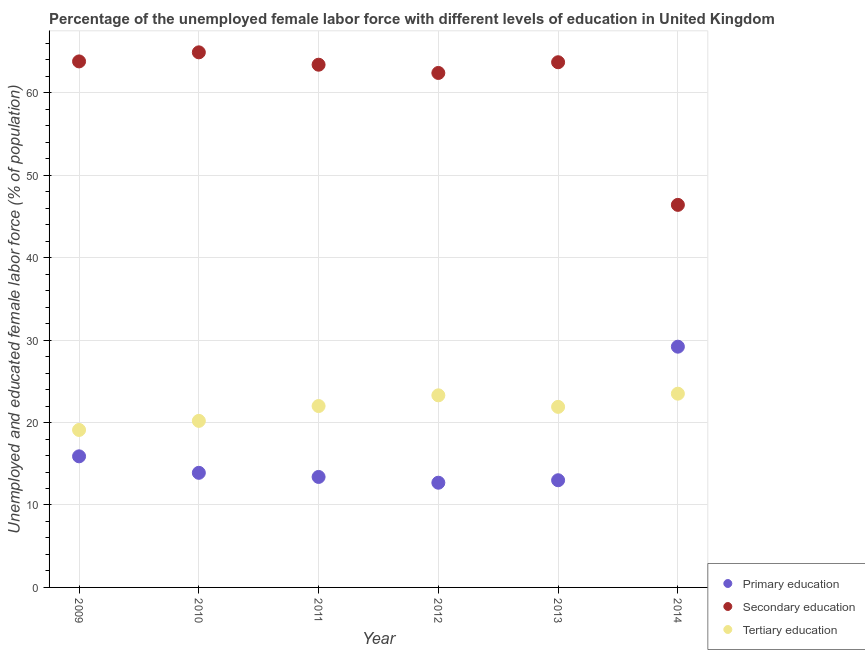How many different coloured dotlines are there?
Your answer should be compact. 3. Is the number of dotlines equal to the number of legend labels?
Offer a terse response. Yes. What is the percentage of female labor force who received primary education in 2011?
Ensure brevity in your answer.  13.4. Across all years, what is the minimum percentage of female labor force who received tertiary education?
Offer a terse response. 19.1. In which year was the percentage of female labor force who received secondary education maximum?
Your answer should be very brief. 2010. In which year was the percentage of female labor force who received secondary education minimum?
Offer a very short reply. 2014. What is the total percentage of female labor force who received tertiary education in the graph?
Your response must be concise. 130. What is the difference between the percentage of female labor force who received tertiary education in 2010 and that in 2011?
Your answer should be very brief. -1.8. What is the difference between the percentage of female labor force who received primary education in 2010 and the percentage of female labor force who received secondary education in 2014?
Ensure brevity in your answer.  -32.5. What is the average percentage of female labor force who received tertiary education per year?
Your answer should be very brief. 21.67. In the year 2010, what is the difference between the percentage of female labor force who received tertiary education and percentage of female labor force who received secondary education?
Your answer should be very brief. -44.7. In how many years, is the percentage of female labor force who received primary education greater than 58 %?
Make the answer very short. 0. What is the ratio of the percentage of female labor force who received primary education in 2009 to that in 2011?
Give a very brief answer. 1.19. Is the percentage of female labor force who received tertiary education in 2012 less than that in 2013?
Offer a terse response. No. What is the difference between the highest and the second highest percentage of female labor force who received tertiary education?
Offer a very short reply. 0.2. What is the difference between the highest and the lowest percentage of female labor force who received tertiary education?
Your answer should be very brief. 4.4. In how many years, is the percentage of female labor force who received secondary education greater than the average percentage of female labor force who received secondary education taken over all years?
Make the answer very short. 5. Is it the case that in every year, the sum of the percentage of female labor force who received primary education and percentage of female labor force who received secondary education is greater than the percentage of female labor force who received tertiary education?
Offer a very short reply. Yes. Does the percentage of female labor force who received primary education monotonically increase over the years?
Your answer should be very brief. No. How many dotlines are there?
Provide a short and direct response. 3. What is the difference between two consecutive major ticks on the Y-axis?
Offer a very short reply. 10. How many legend labels are there?
Make the answer very short. 3. What is the title of the graph?
Keep it short and to the point. Percentage of the unemployed female labor force with different levels of education in United Kingdom. What is the label or title of the X-axis?
Provide a short and direct response. Year. What is the label or title of the Y-axis?
Your answer should be compact. Unemployed and educated female labor force (% of population). What is the Unemployed and educated female labor force (% of population) in Primary education in 2009?
Offer a terse response. 15.9. What is the Unemployed and educated female labor force (% of population) in Secondary education in 2009?
Your response must be concise. 63.8. What is the Unemployed and educated female labor force (% of population) of Tertiary education in 2009?
Offer a very short reply. 19.1. What is the Unemployed and educated female labor force (% of population) in Primary education in 2010?
Provide a short and direct response. 13.9. What is the Unemployed and educated female labor force (% of population) in Secondary education in 2010?
Offer a terse response. 64.9. What is the Unemployed and educated female labor force (% of population) of Tertiary education in 2010?
Offer a terse response. 20.2. What is the Unemployed and educated female labor force (% of population) of Primary education in 2011?
Provide a succinct answer. 13.4. What is the Unemployed and educated female labor force (% of population) in Secondary education in 2011?
Provide a succinct answer. 63.4. What is the Unemployed and educated female labor force (% of population) of Primary education in 2012?
Offer a terse response. 12.7. What is the Unemployed and educated female labor force (% of population) of Secondary education in 2012?
Provide a succinct answer. 62.4. What is the Unemployed and educated female labor force (% of population) of Tertiary education in 2012?
Keep it short and to the point. 23.3. What is the Unemployed and educated female labor force (% of population) of Secondary education in 2013?
Make the answer very short. 63.7. What is the Unemployed and educated female labor force (% of population) in Tertiary education in 2013?
Make the answer very short. 21.9. What is the Unemployed and educated female labor force (% of population) of Primary education in 2014?
Make the answer very short. 29.2. What is the Unemployed and educated female labor force (% of population) in Secondary education in 2014?
Provide a succinct answer. 46.4. What is the Unemployed and educated female labor force (% of population) in Tertiary education in 2014?
Provide a short and direct response. 23.5. Across all years, what is the maximum Unemployed and educated female labor force (% of population) of Primary education?
Your answer should be compact. 29.2. Across all years, what is the maximum Unemployed and educated female labor force (% of population) in Secondary education?
Make the answer very short. 64.9. Across all years, what is the minimum Unemployed and educated female labor force (% of population) in Primary education?
Make the answer very short. 12.7. Across all years, what is the minimum Unemployed and educated female labor force (% of population) of Secondary education?
Keep it short and to the point. 46.4. Across all years, what is the minimum Unemployed and educated female labor force (% of population) of Tertiary education?
Provide a short and direct response. 19.1. What is the total Unemployed and educated female labor force (% of population) in Primary education in the graph?
Keep it short and to the point. 98.1. What is the total Unemployed and educated female labor force (% of population) of Secondary education in the graph?
Your answer should be compact. 364.6. What is the total Unemployed and educated female labor force (% of population) of Tertiary education in the graph?
Keep it short and to the point. 130. What is the difference between the Unemployed and educated female labor force (% of population) in Primary education in 2009 and that in 2010?
Give a very brief answer. 2. What is the difference between the Unemployed and educated female labor force (% of population) in Secondary education in 2009 and that in 2010?
Your answer should be compact. -1.1. What is the difference between the Unemployed and educated female labor force (% of population) of Tertiary education in 2009 and that in 2011?
Keep it short and to the point. -2.9. What is the difference between the Unemployed and educated female labor force (% of population) of Primary education in 2009 and that in 2012?
Give a very brief answer. 3.2. What is the difference between the Unemployed and educated female labor force (% of population) in Secondary education in 2009 and that in 2012?
Your answer should be compact. 1.4. What is the difference between the Unemployed and educated female labor force (% of population) of Tertiary education in 2009 and that in 2014?
Your response must be concise. -4.4. What is the difference between the Unemployed and educated female labor force (% of population) of Secondary education in 2010 and that in 2011?
Your response must be concise. 1.5. What is the difference between the Unemployed and educated female labor force (% of population) in Primary education in 2010 and that in 2012?
Give a very brief answer. 1.2. What is the difference between the Unemployed and educated female labor force (% of population) of Tertiary education in 2010 and that in 2012?
Your answer should be very brief. -3.1. What is the difference between the Unemployed and educated female labor force (% of population) in Secondary education in 2010 and that in 2013?
Ensure brevity in your answer.  1.2. What is the difference between the Unemployed and educated female labor force (% of population) of Primary education in 2010 and that in 2014?
Offer a very short reply. -15.3. What is the difference between the Unemployed and educated female labor force (% of population) in Secondary education in 2010 and that in 2014?
Your answer should be very brief. 18.5. What is the difference between the Unemployed and educated female labor force (% of population) in Tertiary education in 2010 and that in 2014?
Offer a very short reply. -3.3. What is the difference between the Unemployed and educated female labor force (% of population) in Primary education in 2011 and that in 2012?
Your answer should be very brief. 0.7. What is the difference between the Unemployed and educated female labor force (% of population) in Tertiary education in 2011 and that in 2012?
Provide a short and direct response. -1.3. What is the difference between the Unemployed and educated female labor force (% of population) in Secondary education in 2011 and that in 2013?
Your answer should be compact. -0.3. What is the difference between the Unemployed and educated female labor force (% of population) of Tertiary education in 2011 and that in 2013?
Ensure brevity in your answer.  0.1. What is the difference between the Unemployed and educated female labor force (% of population) of Primary education in 2011 and that in 2014?
Provide a short and direct response. -15.8. What is the difference between the Unemployed and educated female labor force (% of population) of Secondary education in 2011 and that in 2014?
Offer a very short reply. 17. What is the difference between the Unemployed and educated female labor force (% of population) of Tertiary education in 2012 and that in 2013?
Your answer should be very brief. 1.4. What is the difference between the Unemployed and educated female labor force (% of population) in Primary education in 2012 and that in 2014?
Your response must be concise. -16.5. What is the difference between the Unemployed and educated female labor force (% of population) in Tertiary education in 2012 and that in 2014?
Ensure brevity in your answer.  -0.2. What is the difference between the Unemployed and educated female labor force (% of population) in Primary education in 2013 and that in 2014?
Your response must be concise. -16.2. What is the difference between the Unemployed and educated female labor force (% of population) in Secondary education in 2013 and that in 2014?
Your response must be concise. 17.3. What is the difference between the Unemployed and educated female labor force (% of population) of Tertiary education in 2013 and that in 2014?
Your response must be concise. -1.6. What is the difference between the Unemployed and educated female labor force (% of population) in Primary education in 2009 and the Unemployed and educated female labor force (% of population) in Secondary education in 2010?
Your answer should be compact. -49. What is the difference between the Unemployed and educated female labor force (% of population) in Secondary education in 2009 and the Unemployed and educated female labor force (% of population) in Tertiary education in 2010?
Your response must be concise. 43.6. What is the difference between the Unemployed and educated female labor force (% of population) of Primary education in 2009 and the Unemployed and educated female labor force (% of population) of Secondary education in 2011?
Your answer should be compact. -47.5. What is the difference between the Unemployed and educated female labor force (% of population) of Secondary education in 2009 and the Unemployed and educated female labor force (% of population) of Tertiary education in 2011?
Make the answer very short. 41.8. What is the difference between the Unemployed and educated female labor force (% of population) of Primary education in 2009 and the Unemployed and educated female labor force (% of population) of Secondary education in 2012?
Your answer should be compact. -46.5. What is the difference between the Unemployed and educated female labor force (% of population) of Primary education in 2009 and the Unemployed and educated female labor force (% of population) of Tertiary education in 2012?
Make the answer very short. -7.4. What is the difference between the Unemployed and educated female labor force (% of population) in Secondary education in 2009 and the Unemployed and educated female labor force (% of population) in Tertiary education in 2012?
Give a very brief answer. 40.5. What is the difference between the Unemployed and educated female labor force (% of population) in Primary education in 2009 and the Unemployed and educated female labor force (% of population) in Secondary education in 2013?
Provide a short and direct response. -47.8. What is the difference between the Unemployed and educated female labor force (% of population) in Primary education in 2009 and the Unemployed and educated female labor force (% of population) in Tertiary education in 2013?
Your answer should be very brief. -6. What is the difference between the Unemployed and educated female labor force (% of population) in Secondary education in 2009 and the Unemployed and educated female labor force (% of population) in Tertiary education in 2013?
Make the answer very short. 41.9. What is the difference between the Unemployed and educated female labor force (% of population) of Primary education in 2009 and the Unemployed and educated female labor force (% of population) of Secondary education in 2014?
Your answer should be compact. -30.5. What is the difference between the Unemployed and educated female labor force (% of population) in Secondary education in 2009 and the Unemployed and educated female labor force (% of population) in Tertiary education in 2014?
Make the answer very short. 40.3. What is the difference between the Unemployed and educated female labor force (% of population) in Primary education in 2010 and the Unemployed and educated female labor force (% of population) in Secondary education in 2011?
Your answer should be very brief. -49.5. What is the difference between the Unemployed and educated female labor force (% of population) in Primary education in 2010 and the Unemployed and educated female labor force (% of population) in Tertiary education in 2011?
Ensure brevity in your answer.  -8.1. What is the difference between the Unemployed and educated female labor force (% of population) of Secondary education in 2010 and the Unemployed and educated female labor force (% of population) of Tertiary education in 2011?
Your answer should be compact. 42.9. What is the difference between the Unemployed and educated female labor force (% of population) in Primary education in 2010 and the Unemployed and educated female labor force (% of population) in Secondary education in 2012?
Ensure brevity in your answer.  -48.5. What is the difference between the Unemployed and educated female labor force (% of population) of Secondary education in 2010 and the Unemployed and educated female labor force (% of population) of Tertiary education in 2012?
Your answer should be very brief. 41.6. What is the difference between the Unemployed and educated female labor force (% of population) of Primary education in 2010 and the Unemployed and educated female labor force (% of population) of Secondary education in 2013?
Make the answer very short. -49.8. What is the difference between the Unemployed and educated female labor force (% of population) in Primary education in 2010 and the Unemployed and educated female labor force (% of population) in Tertiary education in 2013?
Keep it short and to the point. -8. What is the difference between the Unemployed and educated female labor force (% of population) in Secondary education in 2010 and the Unemployed and educated female labor force (% of population) in Tertiary education in 2013?
Provide a short and direct response. 43. What is the difference between the Unemployed and educated female labor force (% of population) in Primary education in 2010 and the Unemployed and educated female labor force (% of population) in Secondary education in 2014?
Your answer should be very brief. -32.5. What is the difference between the Unemployed and educated female labor force (% of population) in Primary education in 2010 and the Unemployed and educated female labor force (% of population) in Tertiary education in 2014?
Keep it short and to the point. -9.6. What is the difference between the Unemployed and educated female labor force (% of population) in Secondary education in 2010 and the Unemployed and educated female labor force (% of population) in Tertiary education in 2014?
Your response must be concise. 41.4. What is the difference between the Unemployed and educated female labor force (% of population) of Primary education in 2011 and the Unemployed and educated female labor force (% of population) of Secondary education in 2012?
Provide a short and direct response. -49. What is the difference between the Unemployed and educated female labor force (% of population) in Secondary education in 2011 and the Unemployed and educated female labor force (% of population) in Tertiary education in 2012?
Offer a terse response. 40.1. What is the difference between the Unemployed and educated female labor force (% of population) in Primary education in 2011 and the Unemployed and educated female labor force (% of population) in Secondary education in 2013?
Offer a terse response. -50.3. What is the difference between the Unemployed and educated female labor force (% of population) of Primary education in 2011 and the Unemployed and educated female labor force (% of population) of Tertiary education in 2013?
Your response must be concise. -8.5. What is the difference between the Unemployed and educated female labor force (% of population) in Secondary education in 2011 and the Unemployed and educated female labor force (% of population) in Tertiary education in 2013?
Offer a very short reply. 41.5. What is the difference between the Unemployed and educated female labor force (% of population) of Primary education in 2011 and the Unemployed and educated female labor force (% of population) of Secondary education in 2014?
Make the answer very short. -33. What is the difference between the Unemployed and educated female labor force (% of population) in Primary education in 2011 and the Unemployed and educated female labor force (% of population) in Tertiary education in 2014?
Keep it short and to the point. -10.1. What is the difference between the Unemployed and educated female labor force (% of population) of Secondary education in 2011 and the Unemployed and educated female labor force (% of population) of Tertiary education in 2014?
Keep it short and to the point. 39.9. What is the difference between the Unemployed and educated female labor force (% of population) of Primary education in 2012 and the Unemployed and educated female labor force (% of population) of Secondary education in 2013?
Provide a short and direct response. -51. What is the difference between the Unemployed and educated female labor force (% of population) in Secondary education in 2012 and the Unemployed and educated female labor force (% of population) in Tertiary education in 2013?
Your response must be concise. 40.5. What is the difference between the Unemployed and educated female labor force (% of population) of Primary education in 2012 and the Unemployed and educated female labor force (% of population) of Secondary education in 2014?
Provide a short and direct response. -33.7. What is the difference between the Unemployed and educated female labor force (% of population) in Secondary education in 2012 and the Unemployed and educated female labor force (% of population) in Tertiary education in 2014?
Provide a succinct answer. 38.9. What is the difference between the Unemployed and educated female labor force (% of population) of Primary education in 2013 and the Unemployed and educated female labor force (% of population) of Secondary education in 2014?
Your response must be concise. -33.4. What is the difference between the Unemployed and educated female labor force (% of population) of Secondary education in 2013 and the Unemployed and educated female labor force (% of population) of Tertiary education in 2014?
Keep it short and to the point. 40.2. What is the average Unemployed and educated female labor force (% of population) of Primary education per year?
Your answer should be very brief. 16.35. What is the average Unemployed and educated female labor force (% of population) in Secondary education per year?
Your response must be concise. 60.77. What is the average Unemployed and educated female labor force (% of population) in Tertiary education per year?
Keep it short and to the point. 21.67. In the year 2009, what is the difference between the Unemployed and educated female labor force (% of population) in Primary education and Unemployed and educated female labor force (% of population) in Secondary education?
Give a very brief answer. -47.9. In the year 2009, what is the difference between the Unemployed and educated female labor force (% of population) in Primary education and Unemployed and educated female labor force (% of population) in Tertiary education?
Ensure brevity in your answer.  -3.2. In the year 2009, what is the difference between the Unemployed and educated female labor force (% of population) of Secondary education and Unemployed and educated female labor force (% of population) of Tertiary education?
Your answer should be compact. 44.7. In the year 2010, what is the difference between the Unemployed and educated female labor force (% of population) of Primary education and Unemployed and educated female labor force (% of population) of Secondary education?
Ensure brevity in your answer.  -51. In the year 2010, what is the difference between the Unemployed and educated female labor force (% of population) of Secondary education and Unemployed and educated female labor force (% of population) of Tertiary education?
Ensure brevity in your answer.  44.7. In the year 2011, what is the difference between the Unemployed and educated female labor force (% of population) of Secondary education and Unemployed and educated female labor force (% of population) of Tertiary education?
Ensure brevity in your answer.  41.4. In the year 2012, what is the difference between the Unemployed and educated female labor force (% of population) of Primary education and Unemployed and educated female labor force (% of population) of Secondary education?
Make the answer very short. -49.7. In the year 2012, what is the difference between the Unemployed and educated female labor force (% of population) of Secondary education and Unemployed and educated female labor force (% of population) of Tertiary education?
Offer a terse response. 39.1. In the year 2013, what is the difference between the Unemployed and educated female labor force (% of population) in Primary education and Unemployed and educated female labor force (% of population) in Secondary education?
Give a very brief answer. -50.7. In the year 2013, what is the difference between the Unemployed and educated female labor force (% of population) of Secondary education and Unemployed and educated female labor force (% of population) of Tertiary education?
Your response must be concise. 41.8. In the year 2014, what is the difference between the Unemployed and educated female labor force (% of population) of Primary education and Unemployed and educated female labor force (% of population) of Secondary education?
Offer a terse response. -17.2. In the year 2014, what is the difference between the Unemployed and educated female labor force (% of population) of Primary education and Unemployed and educated female labor force (% of population) of Tertiary education?
Your response must be concise. 5.7. In the year 2014, what is the difference between the Unemployed and educated female labor force (% of population) in Secondary education and Unemployed and educated female labor force (% of population) in Tertiary education?
Your answer should be very brief. 22.9. What is the ratio of the Unemployed and educated female labor force (% of population) of Primary education in 2009 to that in 2010?
Keep it short and to the point. 1.14. What is the ratio of the Unemployed and educated female labor force (% of population) of Secondary education in 2009 to that in 2010?
Your answer should be very brief. 0.98. What is the ratio of the Unemployed and educated female labor force (% of population) of Tertiary education in 2009 to that in 2010?
Make the answer very short. 0.95. What is the ratio of the Unemployed and educated female labor force (% of population) of Primary education in 2009 to that in 2011?
Keep it short and to the point. 1.19. What is the ratio of the Unemployed and educated female labor force (% of population) of Tertiary education in 2009 to that in 2011?
Give a very brief answer. 0.87. What is the ratio of the Unemployed and educated female labor force (% of population) in Primary education in 2009 to that in 2012?
Provide a succinct answer. 1.25. What is the ratio of the Unemployed and educated female labor force (% of population) of Secondary education in 2009 to that in 2012?
Provide a succinct answer. 1.02. What is the ratio of the Unemployed and educated female labor force (% of population) of Tertiary education in 2009 to that in 2012?
Offer a very short reply. 0.82. What is the ratio of the Unemployed and educated female labor force (% of population) in Primary education in 2009 to that in 2013?
Give a very brief answer. 1.22. What is the ratio of the Unemployed and educated female labor force (% of population) of Secondary education in 2009 to that in 2013?
Offer a very short reply. 1. What is the ratio of the Unemployed and educated female labor force (% of population) in Tertiary education in 2009 to that in 2013?
Give a very brief answer. 0.87. What is the ratio of the Unemployed and educated female labor force (% of population) of Primary education in 2009 to that in 2014?
Offer a very short reply. 0.54. What is the ratio of the Unemployed and educated female labor force (% of population) of Secondary education in 2009 to that in 2014?
Provide a short and direct response. 1.38. What is the ratio of the Unemployed and educated female labor force (% of population) of Tertiary education in 2009 to that in 2014?
Ensure brevity in your answer.  0.81. What is the ratio of the Unemployed and educated female labor force (% of population) in Primary education in 2010 to that in 2011?
Make the answer very short. 1.04. What is the ratio of the Unemployed and educated female labor force (% of population) in Secondary education in 2010 to that in 2011?
Provide a short and direct response. 1.02. What is the ratio of the Unemployed and educated female labor force (% of population) of Tertiary education in 2010 to that in 2011?
Ensure brevity in your answer.  0.92. What is the ratio of the Unemployed and educated female labor force (% of population) in Primary education in 2010 to that in 2012?
Provide a succinct answer. 1.09. What is the ratio of the Unemployed and educated female labor force (% of population) of Secondary education in 2010 to that in 2012?
Make the answer very short. 1.04. What is the ratio of the Unemployed and educated female labor force (% of population) of Tertiary education in 2010 to that in 2012?
Provide a succinct answer. 0.87. What is the ratio of the Unemployed and educated female labor force (% of population) of Primary education in 2010 to that in 2013?
Offer a very short reply. 1.07. What is the ratio of the Unemployed and educated female labor force (% of population) in Secondary education in 2010 to that in 2013?
Keep it short and to the point. 1.02. What is the ratio of the Unemployed and educated female labor force (% of population) of Tertiary education in 2010 to that in 2013?
Provide a succinct answer. 0.92. What is the ratio of the Unemployed and educated female labor force (% of population) in Primary education in 2010 to that in 2014?
Provide a succinct answer. 0.48. What is the ratio of the Unemployed and educated female labor force (% of population) in Secondary education in 2010 to that in 2014?
Your response must be concise. 1.4. What is the ratio of the Unemployed and educated female labor force (% of population) in Tertiary education in 2010 to that in 2014?
Your answer should be compact. 0.86. What is the ratio of the Unemployed and educated female labor force (% of population) in Primary education in 2011 to that in 2012?
Keep it short and to the point. 1.06. What is the ratio of the Unemployed and educated female labor force (% of population) of Tertiary education in 2011 to that in 2012?
Provide a short and direct response. 0.94. What is the ratio of the Unemployed and educated female labor force (% of population) of Primary education in 2011 to that in 2013?
Provide a succinct answer. 1.03. What is the ratio of the Unemployed and educated female labor force (% of population) in Primary education in 2011 to that in 2014?
Your response must be concise. 0.46. What is the ratio of the Unemployed and educated female labor force (% of population) of Secondary education in 2011 to that in 2014?
Keep it short and to the point. 1.37. What is the ratio of the Unemployed and educated female labor force (% of population) of Tertiary education in 2011 to that in 2014?
Ensure brevity in your answer.  0.94. What is the ratio of the Unemployed and educated female labor force (% of population) in Primary education in 2012 to that in 2013?
Provide a short and direct response. 0.98. What is the ratio of the Unemployed and educated female labor force (% of population) of Secondary education in 2012 to that in 2013?
Provide a succinct answer. 0.98. What is the ratio of the Unemployed and educated female labor force (% of population) of Tertiary education in 2012 to that in 2013?
Ensure brevity in your answer.  1.06. What is the ratio of the Unemployed and educated female labor force (% of population) of Primary education in 2012 to that in 2014?
Make the answer very short. 0.43. What is the ratio of the Unemployed and educated female labor force (% of population) in Secondary education in 2012 to that in 2014?
Keep it short and to the point. 1.34. What is the ratio of the Unemployed and educated female labor force (% of population) of Tertiary education in 2012 to that in 2014?
Your answer should be compact. 0.99. What is the ratio of the Unemployed and educated female labor force (% of population) of Primary education in 2013 to that in 2014?
Ensure brevity in your answer.  0.45. What is the ratio of the Unemployed and educated female labor force (% of population) of Secondary education in 2013 to that in 2014?
Provide a succinct answer. 1.37. What is the ratio of the Unemployed and educated female labor force (% of population) in Tertiary education in 2013 to that in 2014?
Provide a short and direct response. 0.93. What is the difference between the highest and the second highest Unemployed and educated female labor force (% of population) of Tertiary education?
Provide a succinct answer. 0.2. What is the difference between the highest and the lowest Unemployed and educated female labor force (% of population) of Secondary education?
Give a very brief answer. 18.5. What is the difference between the highest and the lowest Unemployed and educated female labor force (% of population) of Tertiary education?
Give a very brief answer. 4.4. 